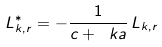Convert formula to latex. <formula><loc_0><loc_0><loc_500><loc_500>L _ { k , r } ^ { * } = - \frac { 1 } { c + \ k a } \, L _ { k , r }</formula> 